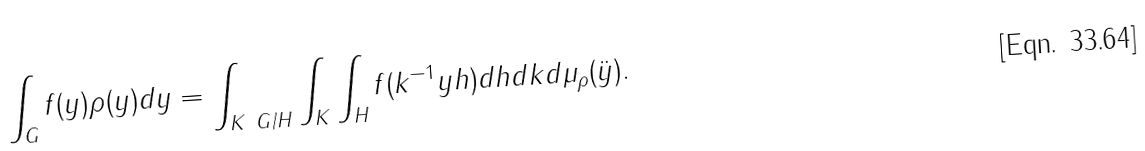<formula> <loc_0><loc_0><loc_500><loc_500>\int _ { G } f ( y ) \rho ( y ) d y & = \int _ { K \ G / H } \int _ { K } \int _ { H } f ( k ^ { - 1 } y h ) d h d k d \mu _ { \rho } ( \ddot { y } ) .</formula> 